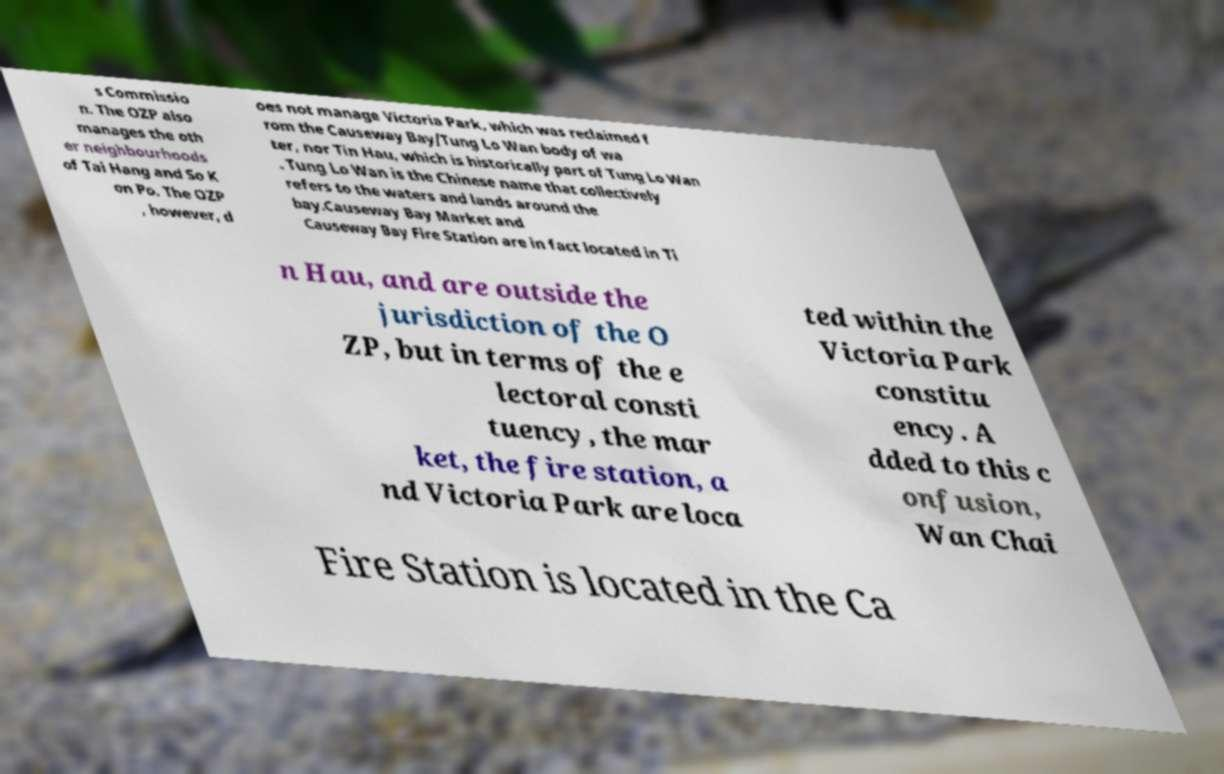Could you extract and type out the text from this image? s Commissio n. The OZP also manages the oth er neighbourhoods of Tai Hang and So K on Po. The OZP , however, d oes not manage Victoria Park, which was reclaimed f rom the Causeway Bay/Tung Lo Wan body of wa ter, nor Tin Hau, which is historically part of Tung Lo Wan . Tung Lo Wan is the Chinese name that collectively refers to the waters and lands around the bay.Causeway Bay Market and Causeway Bay Fire Station are in fact located in Ti n Hau, and are outside the jurisdiction of the O ZP, but in terms of the e lectoral consti tuency, the mar ket, the fire station, a nd Victoria Park are loca ted within the Victoria Park constitu ency. A dded to this c onfusion, Wan Chai Fire Station is located in the Ca 